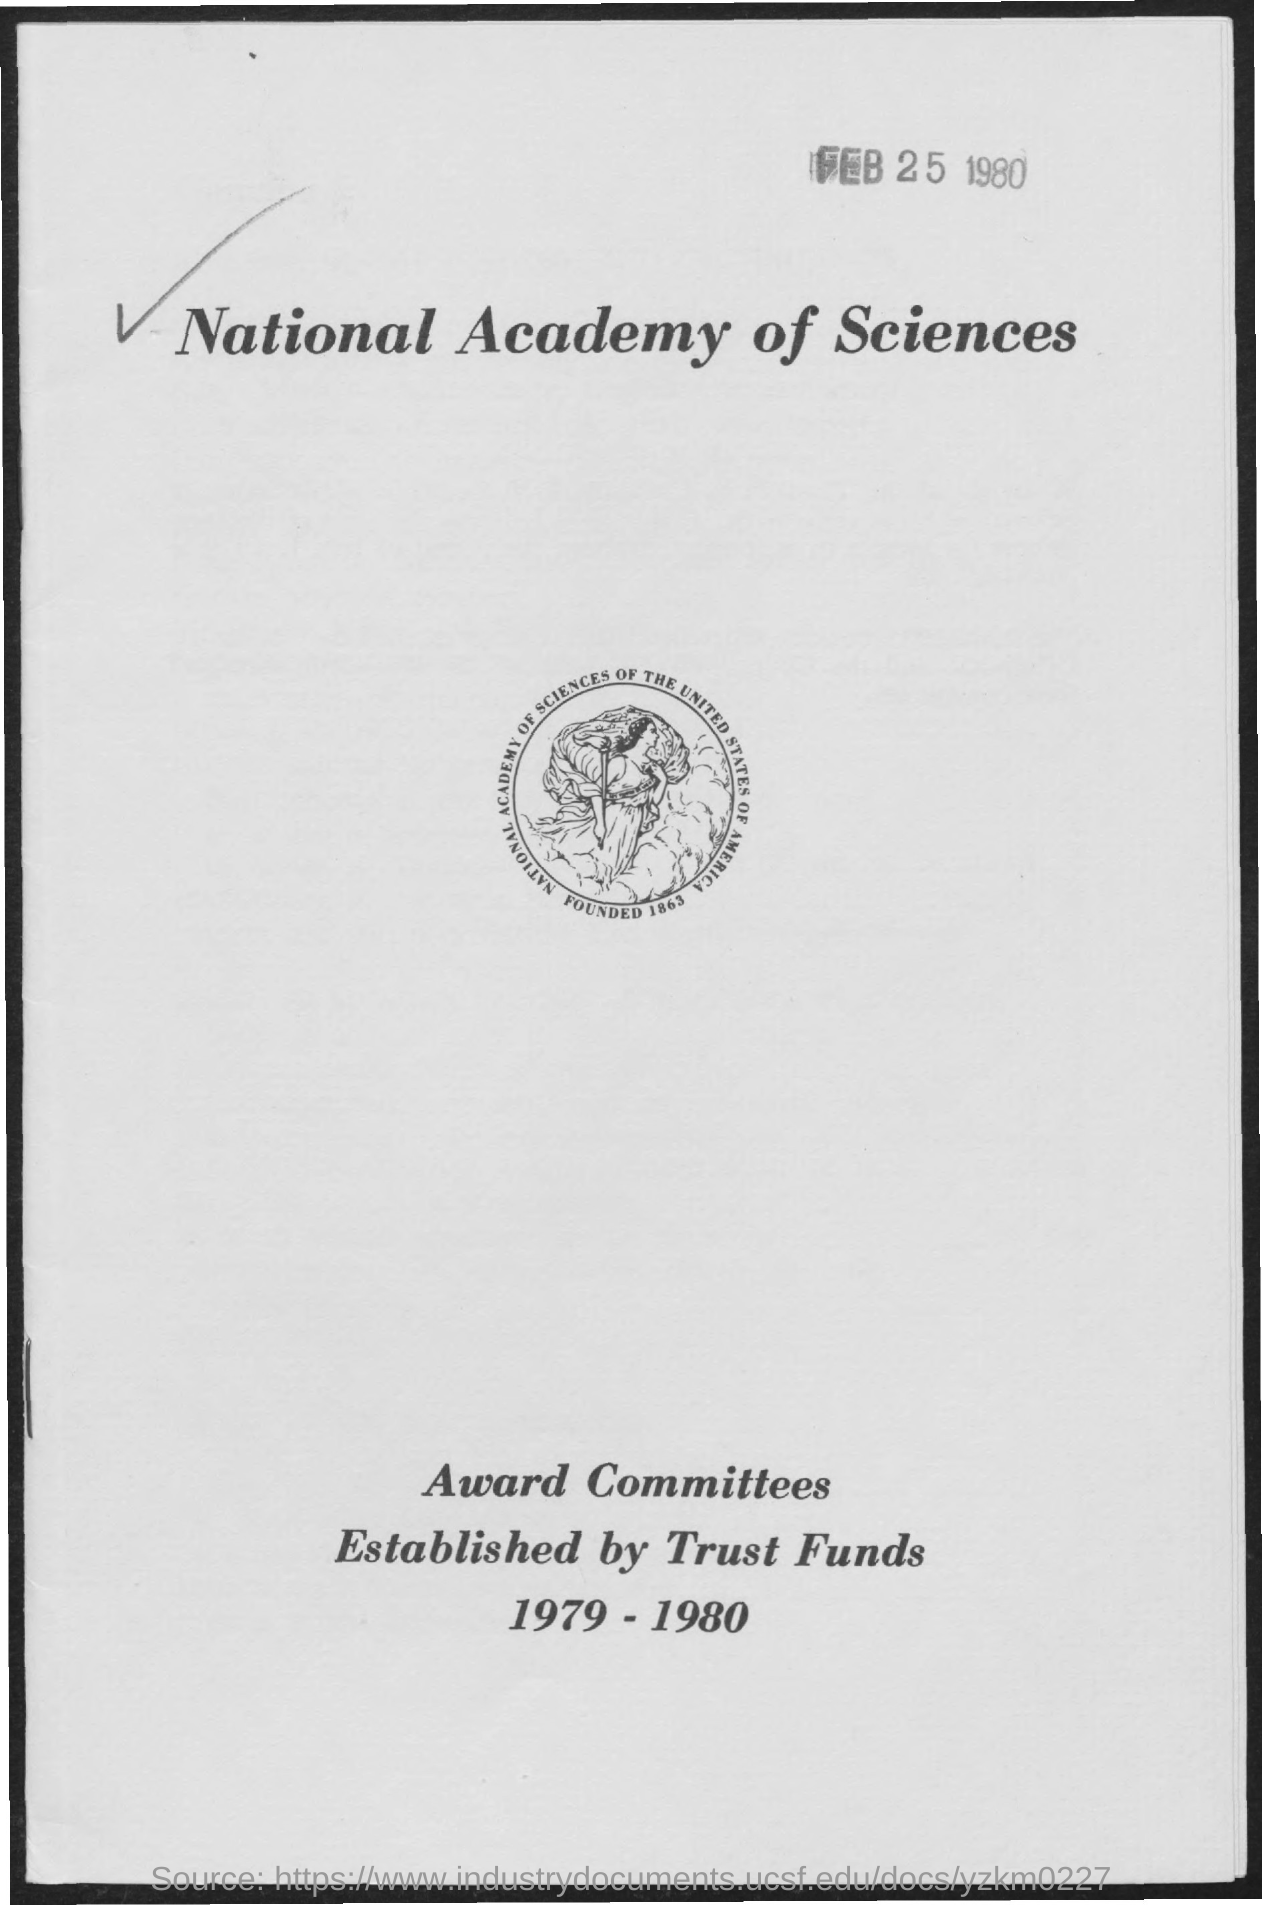Identify some key points in this picture. The National Academy of Sciences of the United States of America was founded in 1863. The date mentioned on the given page is February 25, 1980. 